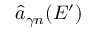<formula> <loc_0><loc_0><loc_500><loc_500>\hat { a } _ { \gamma n } ( E ^ { \prime } )</formula> 